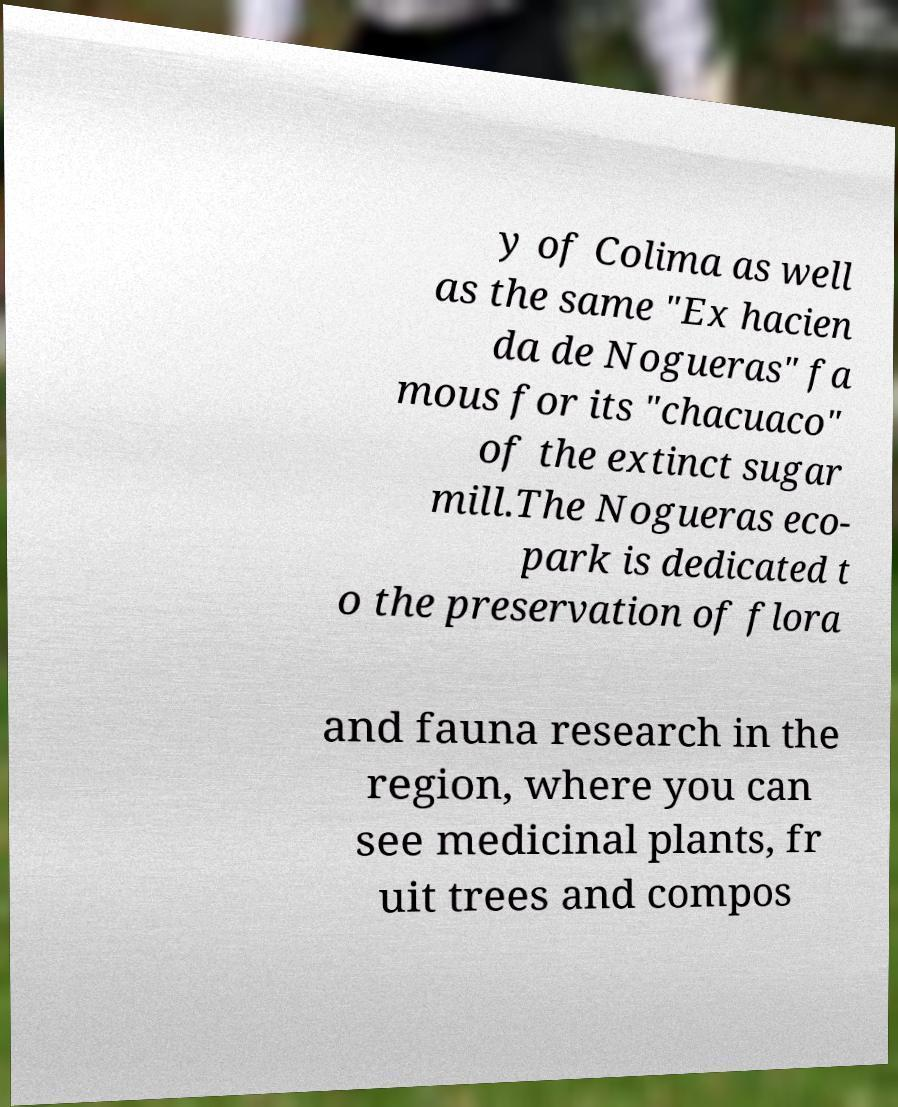Please identify and transcribe the text found in this image. y of Colima as well as the same "Ex hacien da de Nogueras" fa mous for its "chacuaco" of the extinct sugar mill.The Nogueras eco- park is dedicated t o the preservation of flora and fauna research in the region, where you can see medicinal plants, fr uit trees and compos 